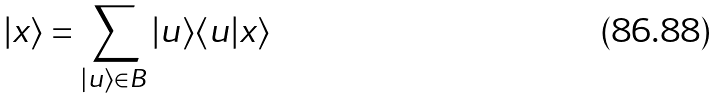Convert formula to latex. <formula><loc_0><loc_0><loc_500><loc_500>| x \rangle = \sum _ { | u \rangle \in B } | u \rangle \langle u | x \rangle</formula> 